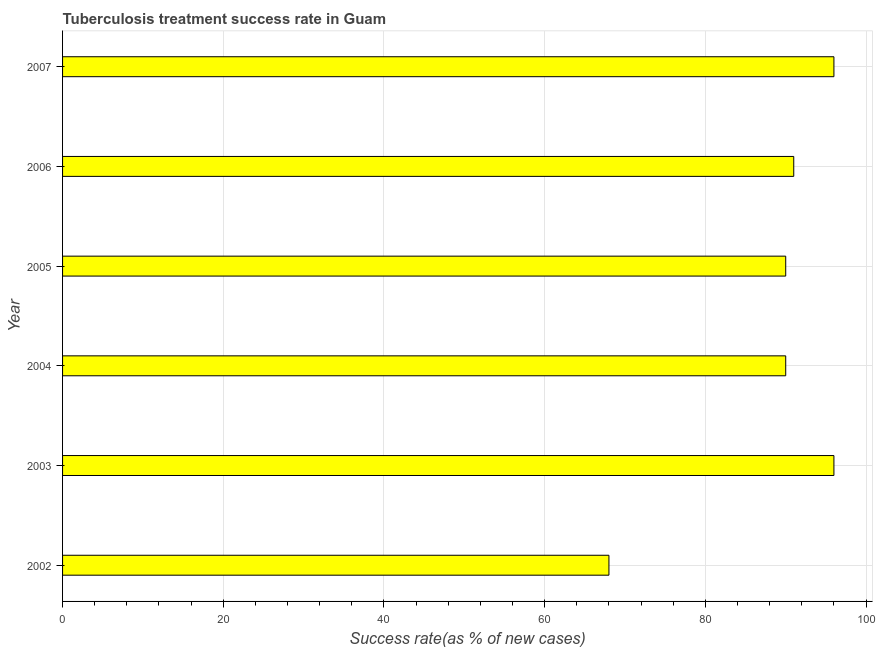Does the graph contain any zero values?
Offer a terse response. No. What is the title of the graph?
Make the answer very short. Tuberculosis treatment success rate in Guam. What is the label or title of the X-axis?
Make the answer very short. Success rate(as % of new cases). What is the tuberculosis treatment success rate in 2006?
Your answer should be compact. 91. Across all years, what is the maximum tuberculosis treatment success rate?
Offer a terse response. 96. Across all years, what is the minimum tuberculosis treatment success rate?
Ensure brevity in your answer.  68. In which year was the tuberculosis treatment success rate maximum?
Offer a very short reply. 2003. What is the sum of the tuberculosis treatment success rate?
Offer a terse response. 531. What is the median tuberculosis treatment success rate?
Offer a terse response. 90.5. Do a majority of the years between 2003 and 2005 (inclusive) have tuberculosis treatment success rate greater than 20 %?
Your answer should be very brief. Yes. What is the ratio of the tuberculosis treatment success rate in 2002 to that in 2004?
Offer a very short reply. 0.76. Is the tuberculosis treatment success rate in 2002 less than that in 2005?
Provide a succinct answer. Yes. Is the difference between the tuberculosis treatment success rate in 2002 and 2006 greater than the difference between any two years?
Make the answer very short. No. Is the sum of the tuberculosis treatment success rate in 2002 and 2006 greater than the maximum tuberculosis treatment success rate across all years?
Ensure brevity in your answer.  Yes. In how many years, is the tuberculosis treatment success rate greater than the average tuberculosis treatment success rate taken over all years?
Provide a succinct answer. 5. How many bars are there?
Provide a succinct answer. 6. Are all the bars in the graph horizontal?
Ensure brevity in your answer.  Yes. Are the values on the major ticks of X-axis written in scientific E-notation?
Your answer should be compact. No. What is the Success rate(as % of new cases) of 2002?
Offer a very short reply. 68. What is the Success rate(as % of new cases) of 2003?
Your answer should be compact. 96. What is the Success rate(as % of new cases) of 2004?
Ensure brevity in your answer.  90. What is the Success rate(as % of new cases) in 2006?
Ensure brevity in your answer.  91. What is the Success rate(as % of new cases) of 2007?
Your answer should be very brief. 96. What is the difference between the Success rate(as % of new cases) in 2002 and 2003?
Offer a very short reply. -28. What is the difference between the Success rate(as % of new cases) in 2002 and 2004?
Offer a very short reply. -22. What is the difference between the Success rate(as % of new cases) in 2003 and 2005?
Your response must be concise. 6. What is the difference between the Success rate(as % of new cases) in 2003 and 2006?
Offer a terse response. 5. What is the difference between the Success rate(as % of new cases) in 2003 and 2007?
Keep it short and to the point. 0. What is the difference between the Success rate(as % of new cases) in 2004 and 2005?
Your answer should be compact. 0. What is the difference between the Success rate(as % of new cases) in 2004 and 2006?
Give a very brief answer. -1. What is the ratio of the Success rate(as % of new cases) in 2002 to that in 2003?
Offer a very short reply. 0.71. What is the ratio of the Success rate(as % of new cases) in 2002 to that in 2004?
Your answer should be very brief. 0.76. What is the ratio of the Success rate(as % of new cases) in 2002 to that in 2005?
Provide a short and direct response. 0.76. What is the ratio of the Success rate(as % of new cases) in 2002 to that in 2006?
Provide a succinct answer. 0.75. What is the ratio of the Success rate(as % of new cases) in 2002 to that in 2007?
Provide a succinct answer. 0.71. What is the ratio of the Success rate(as % of new cases) in 2003 to that in 2004?
Give a very brief answer. 1.07. What is the ratio of the Success rate(as % of new cases) in 2003 to that in 2005?
Keep it short and to the point. 1.07. What is the ratio of the Success rate(as % of new cases) in 2003 to that in 2006?
Provide a short and direct response. 1.05. What is the ratio of the Success rate(as % of new cases) in 2003 to that in 2007?
Keep it short and to the point. 1. What is the ratio of the Success rate(as % of new cases) in 2004 to that in 2005?
Give a very brief answer. 1. What is the ratio of the Success rate(as % of new cases) in 2004 to that in 2007?
Ensure brevity in your answer.  0.94. What is the ratio of the Success rate(as % of new cases) in 2005 to that in 2007?
Provide a short and direct response. 0.94. What is the ratio of the Success rate(as % of new cases) in 2006 to that in 2007?
Make the answer very short. 0.95. 